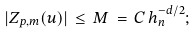<formula> <loc_0><loc_0><loc_500><loc_500>| Z _ { p , m } ( u ) | \, \leq \, M \, = \, C \, h _ { n } ^ { - d / 2 } ;</formula> 